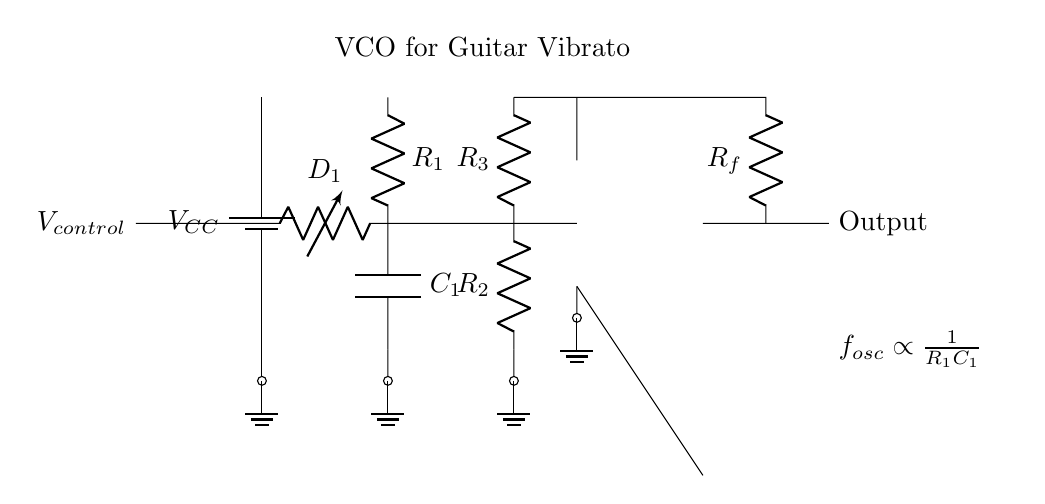What type of oscillator is represented in the circuit? The circuit represents a voltage-controlled oscillator (VCO) since it uses a control voltage to adjust the frequency of oscillation.
Answer: Voltage-controlled oscillator What is the role of the varactor diode in this circuit? The varactor diode allows for voltage control of the circuit’s capacitance, which in turn influences the oscillation frequency.
Answer: Adjusts capacitance What is the relationship between resistance, capacitance, and frequency in this VCO? The frequency of oscillation is inversely proportional to the product of R1 and C1, meaning as either resistance or capacitance increases, frequency decreases.
Answer: Frequency inversely proportional to resistance and capacitance How many resistors are present in the oscillator circuit? There are three resistors indicated in the diagram, labeled as R1, R2, and R3.
Answer: Three resistors What is the output of the voltage-controlled oscillator circuit? The output is derived from the op-amp, indicated as the "Output" node in the circuit diagram.
Answer: Voltage signal What effect does an increase in the control voltage have on the oscillation frequency? An increase in the control voltage decreases the capacitance provided by the varactor, which increases the oscillation frequency, based on the inverse relationship.
Answer: Increases frequency What component provides the feedback in the oscillator circuit? The feedback in the circuit is provided by the resistor labeled Rf, which connects the output back to the circuit.
Answer: Rf (feedback resistor) 